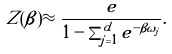<formula> <loc_0><loc_0><loc_500><loc_500>Z ( \beta ) \approx \frac { e } { 1 - \sum _ { j = 1 } ^ { d } e ^ { - \beta \omega _ { j } } } .</formula> 